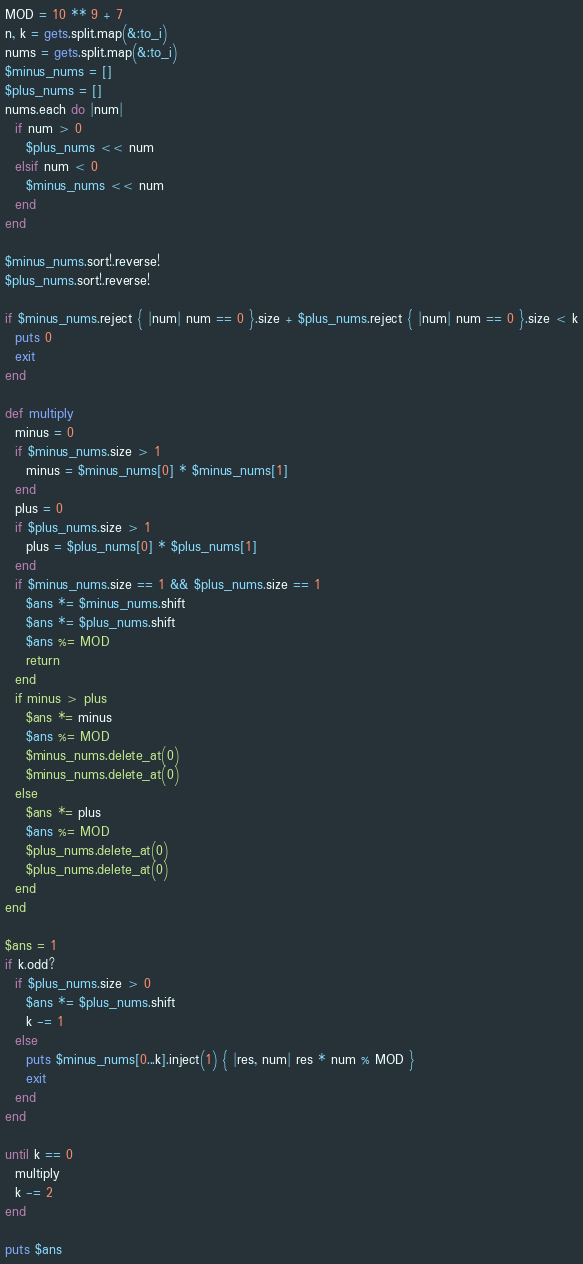<code> <loc_0><loc_0><loc_500><loc_500><_Ruby_>MOD = 10 ** 9 + 7
n, k = gets.split.map(&:to_i)
nums = gets.split.map(&:to_i)
$minus_nums = []
$plus_nums = []
nums.each do |num|
  if num > 0
    $plus_nums << num
  elsif num < 0
    $minus_nums << num
  end
end

$minus_nums.sort!.reverse!
$plus_nums.sort!.reverse!

if $minus_nums.reject { |num| num == 0 }.size + $plus_nums.reject { |num| num == 0 }.size < k
  puts 0
  exit
end

def multiply
  minus = 0
  if $minus_nums.size > 1
    minus = $minus_nums[0] * $minus_nums[1]
  end
  plus = 0
  if $plus_nums.size > 1
    plus = $plus_nums[0] * $plus_nums[1]
  end
  if $minus_nums.size == 1 && $plus_nums.size == 1
    $ans *= $minus_nums.shift
    $ans *= $plus_nums.shift
    $ans %= MOD
    return
  end
  if minus > plus
    $ans *= minus
    $ans %= MOD
    $minus_nums.delete_at(0)
    $minus_nums.delete_at(0)
  else
    $ans *= plus
    $ans %= MOD
    $plus_nums.delete_at(0)
    $plus_nums.delete_at(0)
  end
end

$ans = 1
if k.odd?
  if $plus_nums.size > 0
    $ans *= $plus_nums.shift
    k -= 1
  else
    puts $minus_nums[0...k].inject(1) { |res, num| res * num % MOD }
    exit
  end
end

until k == 0
  multiply
  k -= 2
end

puts $ans
</code> 